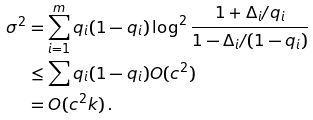<formula> <loc_0><loc_0><loc_500><loc_500>\sigma ^ { 2 } & = \sum _ { i = 1 } ^ { m } q _ { i } ( 1 - q _ { i } ) \log ^ { 2 } \frac { 1 + \Delta _ { i } / q _ { i } } { 1 - \Delta _ { i } / ( 1 - q _ { i } ) } \\ & \leq \sum q _ { i } ( 1 - q _ { i } ) O ( c ^ { 2 } ) \\ & = O ( c ^ { 2 } k ) \, .</formula> 